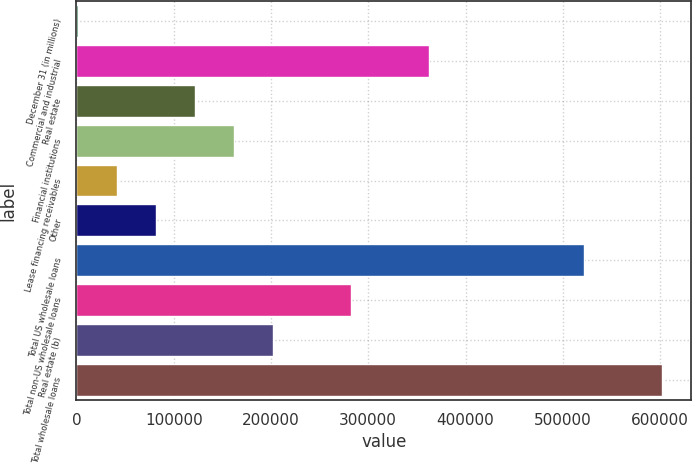Convert chart. <chart><loc_0><loc_0><loc_500><loc_500><bar_chart><fcel>December 31 (in millions)<fcel>Commercial and industrial<fcel>Real estate<fcel>Financial institutions<fcel>Lease financing receivables<fcel>Other<fcel>Total US wholesale loans<fcel>Total non-US wholesale loans<fcel>Real estate (b)<fcel>Total wholesale loans<nl><fcel>2004<fcel>362103<fcel>122037<fcel>162048<fcel>42015<fcel>82026<fcel>522147<fcel>282081<fcel>202059<fcel>602169<nl></chart> 